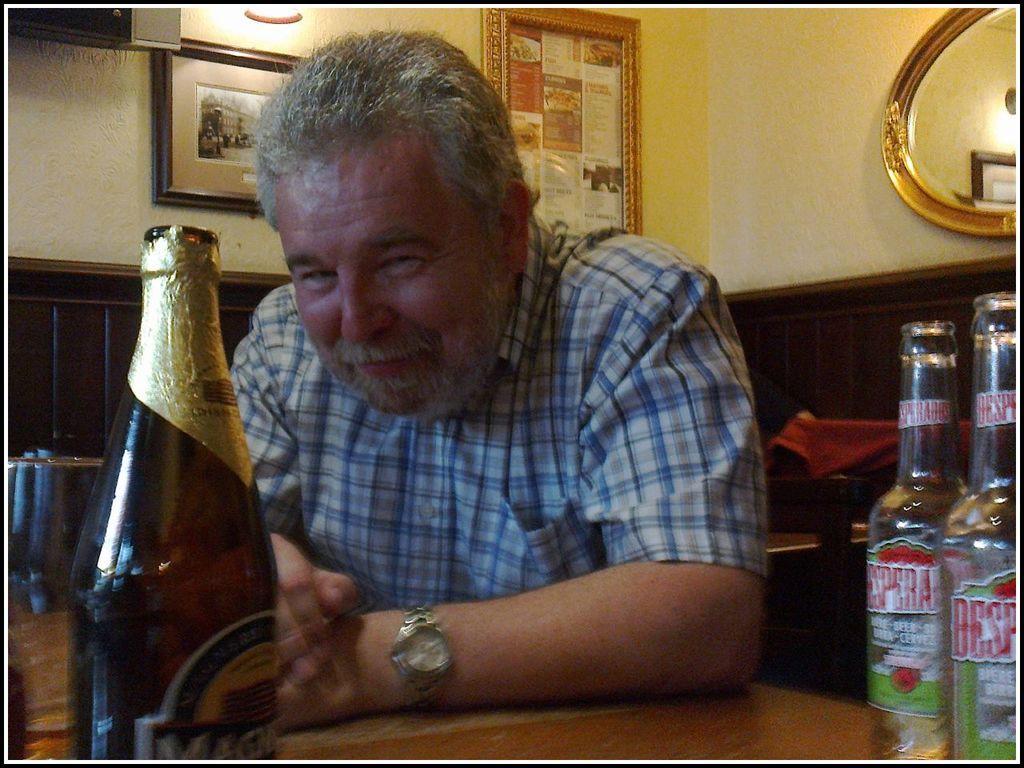Could you give a brief overview of what you see in this image? This picture is clicked inside the room. Here, the man in white and blue checks is wearing watch and he is smiling. In front of him, we see a table on which beer bottle is placed. Behind him, we find a wall on which photo frames are placed and beside that on the right top of the picture, we see mirror. 